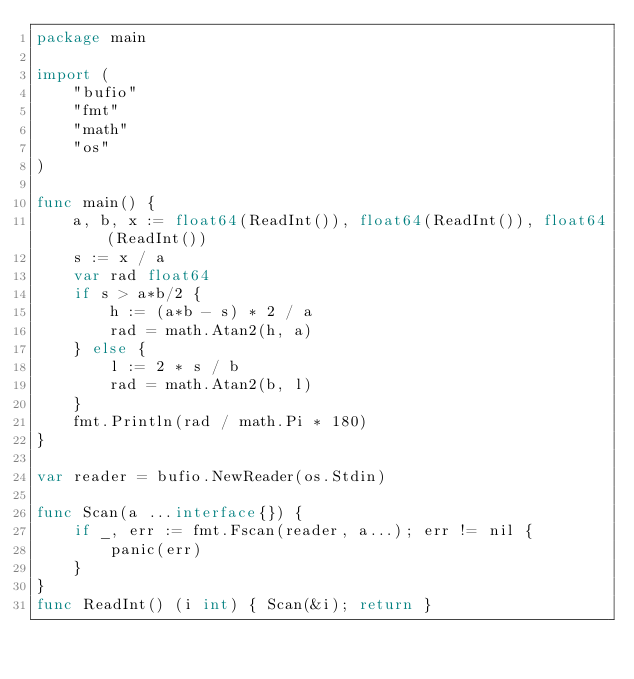<code> <loc_0><loc_0><loc_500><loc_500><_Go_>package main

import (
	"bufio"
	"fmt"
	"math"
	"os"
)

func main() {
	a, b, x := float64(ReadInt()), float64(ReadInt()), float64(ReadInt())
	s := x / a
	var rad float64
	if s > a*b/2 {
		h := (a*b - s) * 2 / a
		rad = math.Atan2(h, a)
	} else {
		l := 2 * s / b
		rad = math.Atan2(b, l)
	}
	fmt.Println(rad / math.Pi * 180)
}

var reader = bufio.NewReader(os.Stdin)

func Scan(a ...interface{}) {
	if _, err := fmt.Fscan(reader, a...); err != nil {
		panic(err)
	}
}
func ReadInt() (i int) { Scan(&i); return }
</code> 